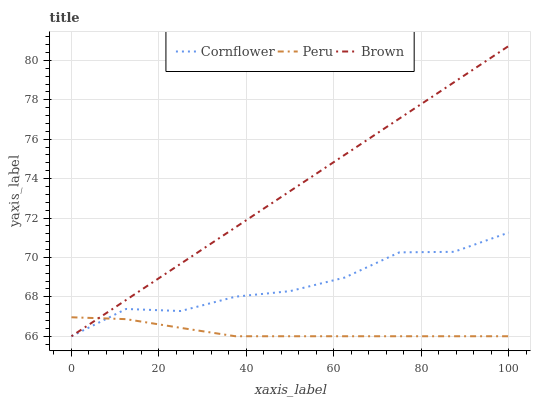Does Peru have the minimum area under the curve?
Answer yes or no. Yes. Does Brown have the maximum area under the curve?
Answer yes or no. Yes. Does Brown have the minimum area under the curve?
Answer yes or no. No. Does Peru have the maximum area under the curve?
Answer yes or no. No. Is Brown the smoothest?
Answer yes or no. Yes. Is Cornflower the roughest?
Answer yes or no. Yes. Is Peru the smoothest?
Answer yes or no. No. Is Peru the roughest?
Answer yes or no. No. Does Cornflower have the lowest value?
Answer yes or no. Yes. Does Brown have the highest value?
Answer yes or no. Yes. Does Peru have the highest value?
Answer yes or no. No. Does Brown intersect Peru?
Answer yes or no. Yes. Is Brown less than Peru?
Answer yes or no. No. Is Brown greater than Peru?
Answer yes or no. No. 